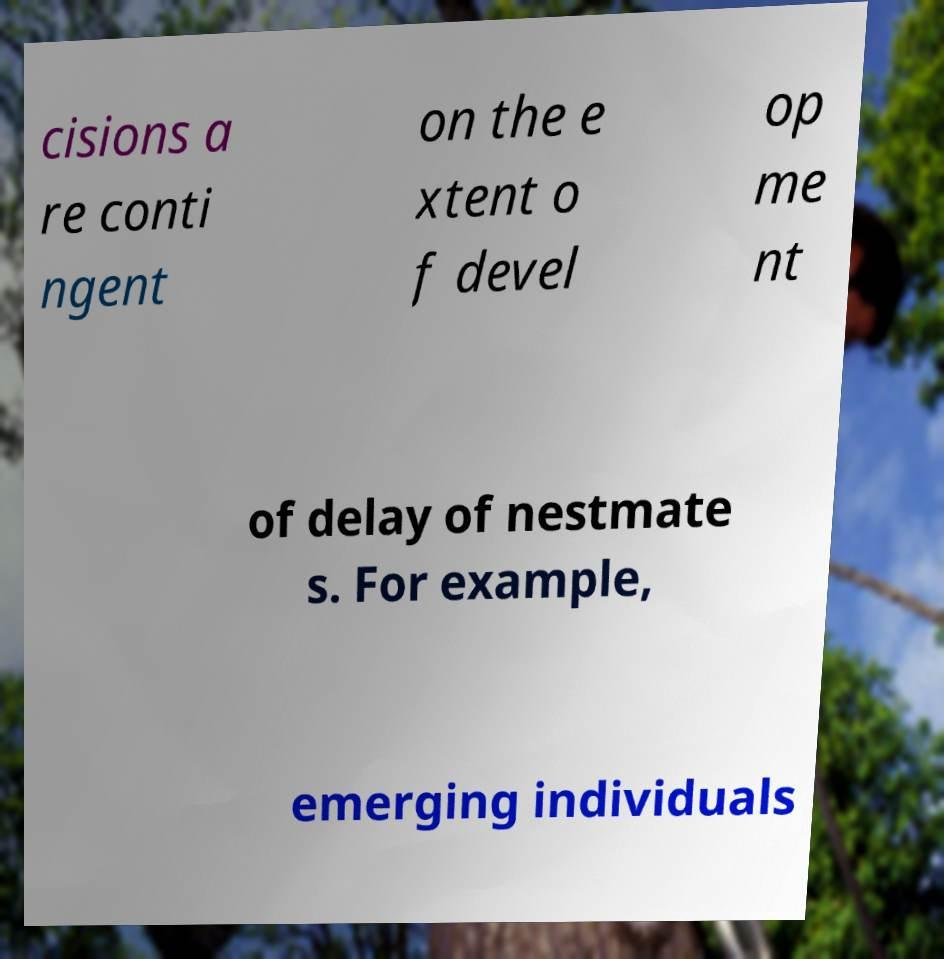For documentation purposes, I need the text within this image transcribed. Could you provide that? cisions a re conti ngent on the e xtent o f devel op me nt of delay of nestmate s. For example, emerging individuals 